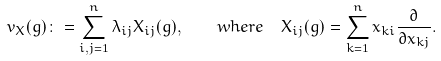Convert formula to latex. <formula><loc_0><loc_0><loc_500><loc_500>v _ { X } ( g ) \colon = \sum _ { i , j = 1 } ^ { n } \lambda _ { i j } X _ { i j } ( g ) , \quad w h e r e \ \ X _ { i j } ( g ) = \sum _ { k = 1 } ^ { n } x _ { k i } \frac { \partial } { \partial x _ { k j } } .</formula> 